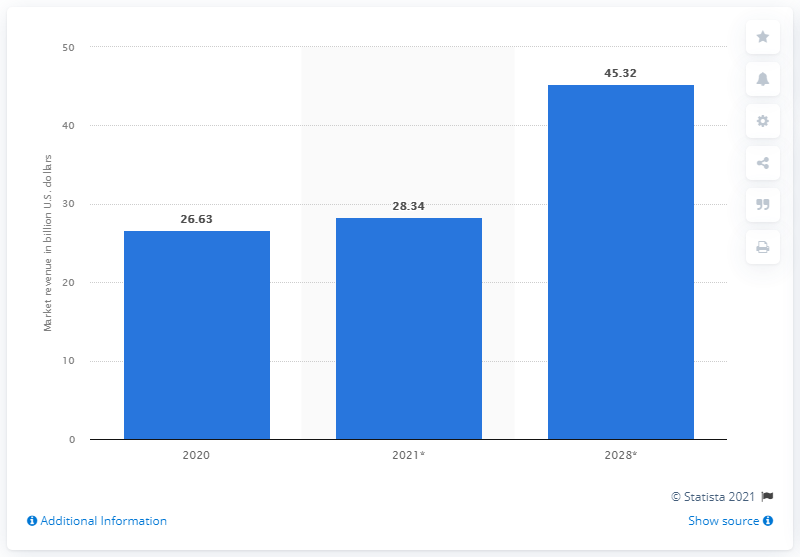Mention a couple of crucial points in this snapshot. The projected size of the global interactive kiosk market in 2028 is 45.32... 